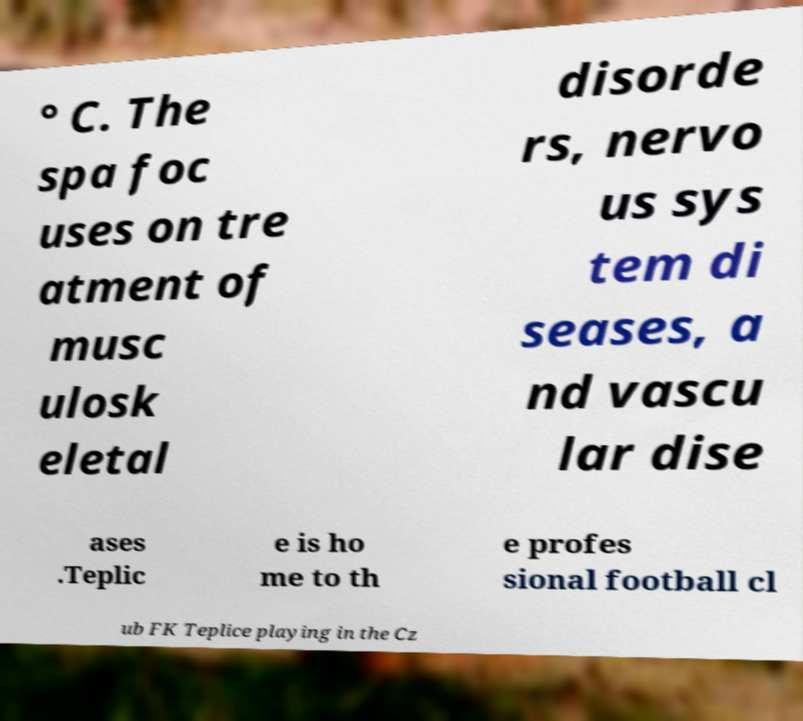Could you extract and type out the text from this image? ° C. The spa foc uses on tre atment of musc ulosk eletal disorde rs, nervo us sys tem di seases, a nd vascu lar dise ases .Teplic e is ho me to th e profes sional football cl ub FK Teplice playing in the Cz 